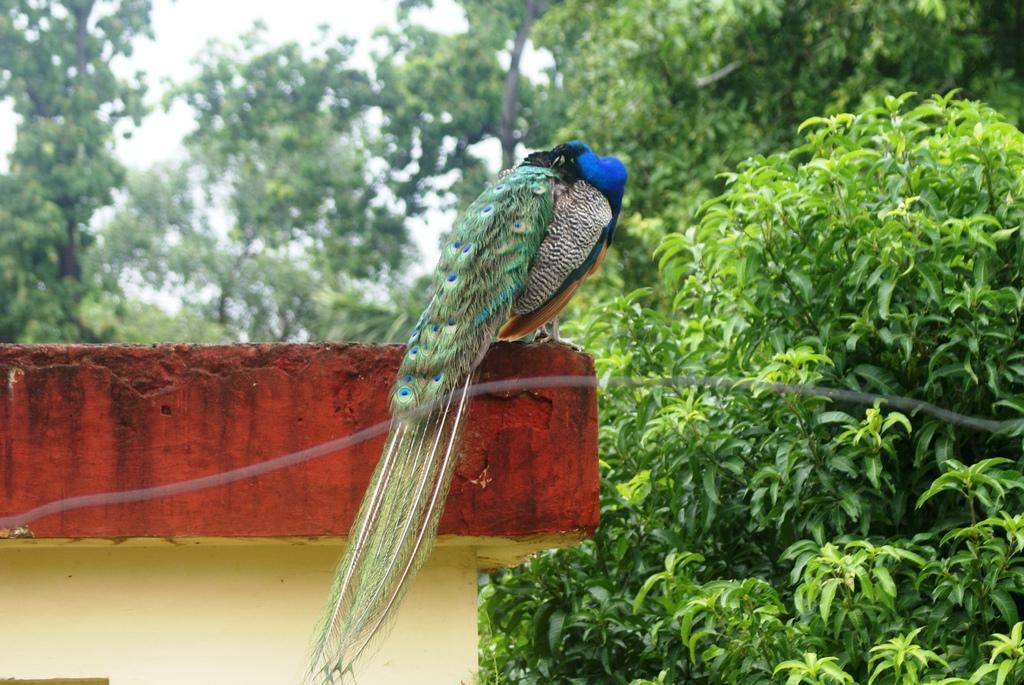Can you describe this image briefly? In this image I can see the bird on the wall and the bird is in green and blue color. In the background I can see few trees in green color and the sky is in white color. 